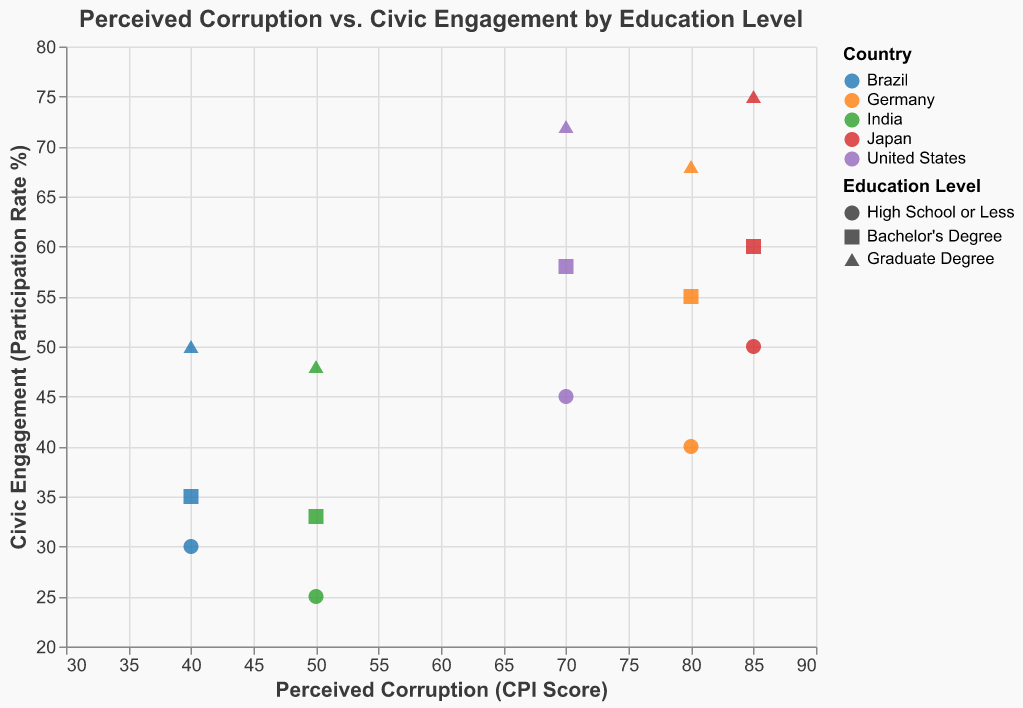What is the title of the figure? The title of the figure is usually located at the top and should describe the primary focus of the plot. In this case, it is "Perceived Corruption vs. Civic Engagement by Education Level."
Answer: Perceived Corruption vs. Civic Engagement by Education Level Which country has the highest perceived corruption score? By looking at the x-axis for the highest Perceived Corruption (CPI Score), Japan has the highest score, which is 85.
Answer: Japan How does civic engagement for people with a Bachelor's Degree compare between the United States and Brazil? To compare, find the points representing the United States and Brazil for "Bachelor's Degree." The civic engagement rate for the United States is 58%, while for Brazil, it is 35%. Comparing these values, the civic engagement rate is higher in the United States.
Answer: Higher in the United States What is the average civic engagement rate for Germany across all education levels? Sum the civic engagement rates across all education levels for Germany and then divide by the number of data points. (40 + 55 + 68) / 3 = 163 / 3 ≈ 54.3%
Answer: 54.3% What patterns can be observed in the relationship between education level and civic engagement within each country? Higher education levels generally correlate with higher civic engagement rates within each country. This pattern can be observed by looking at points with increasing civic engagement as the education level goes from "High School or Less" to "Graduate Degree" in each country.
Answer: Higher education correlates with higher civic engagement Comparing perceived corruption scores, which country has the lowest level, and how does its civic engagement differ across education levels? Brazil has the lowest perceived corruption score of 40. The civic engagement rates for Brazil are 30% (High School or Less), 35% (Bachelor's Degree), and 50% (Graduate Degree). This shows an increase in civic engagement with higher education levels.
Answer: Brazil; civic engagement increases with higher education levels How does civic engagement change between education levels in Japan? In Japan, the civic engagement rates are 50% (High School or Less), 60% (Bachelor's Degree), and 75% (Graduate Degree), showing a consistent increase with higher education levels.
Answer: Increases with higher education levels Which country shows the smallest increase in civic engagement between "High School or Less" and "Bachelor’s Degree"? By comparing the differences between these two education levels for each country, Germany's change in civic engagement is 55% - 40% = 15%, which is the smallest among all countries.
Answer: Germany Is there a country where the perceived corruption score remains the same across all education levels? By examining the x-axis values for all education levels within each country, it is evident that the United States, Germany, Brazil, India, and Japan all have constant perceived corruption scores across their respective education levels.
Answer: Yes Which country has the highest civic engagement for individuals with a Graduate Degree? By looking at the "Graduate Degree" points, Japan has the highest civic engagement at 75%.
Answer: Japan 